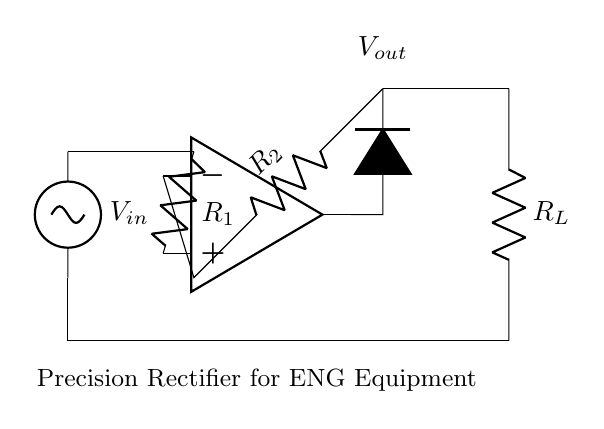What is the input voltage of the circuit? The input voltage is represented by the symbol V_in, which is a standard notation for input voltage in circuits.
Answer: V_in What type of component is used for voltage amplification? The operational amplifier, denoted in the circuit as op amp, is used to amplify the voltage input.
Answer: op amp What does the diode in this circuit do? The diode, represented by D, allows current to flow in one direction and is essential for rectification, converting AC to DC.
Answer: Rectification What is the purpose of R_1 and R_2? R_1 and R_2 are resistors that form a voltage divider and set the gain of the op amp, affecting the precision of the rectifier.
Answer: Setting gain What is the output voltage denoted as in the diagram? The output voltage is indicated by the label V_out, which is the voltage measured at the output of the circuit.
Answer: V_out How does this circuit achieve precision rectification? This circuit achieves precision rectification by using an op amp that allows for accurate measurements of small signals, minimizing errors caused by diode forward voltage.
Answer: Using op amp 